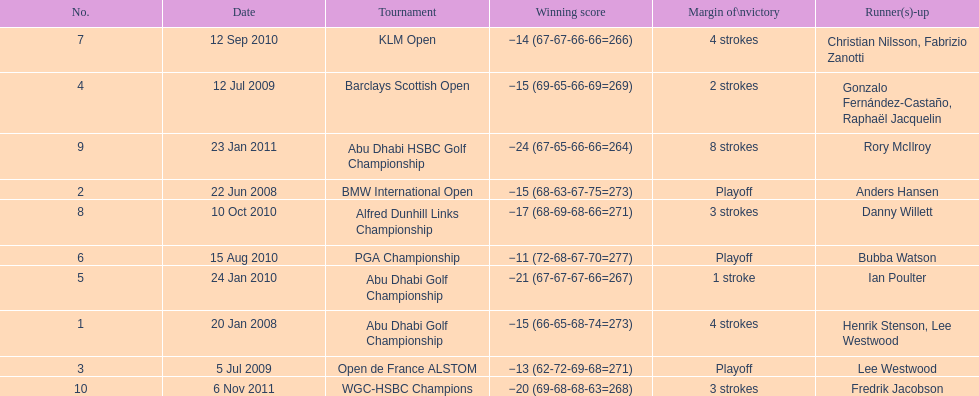How many tournaments has he won by 3 or more strokes? 5. 